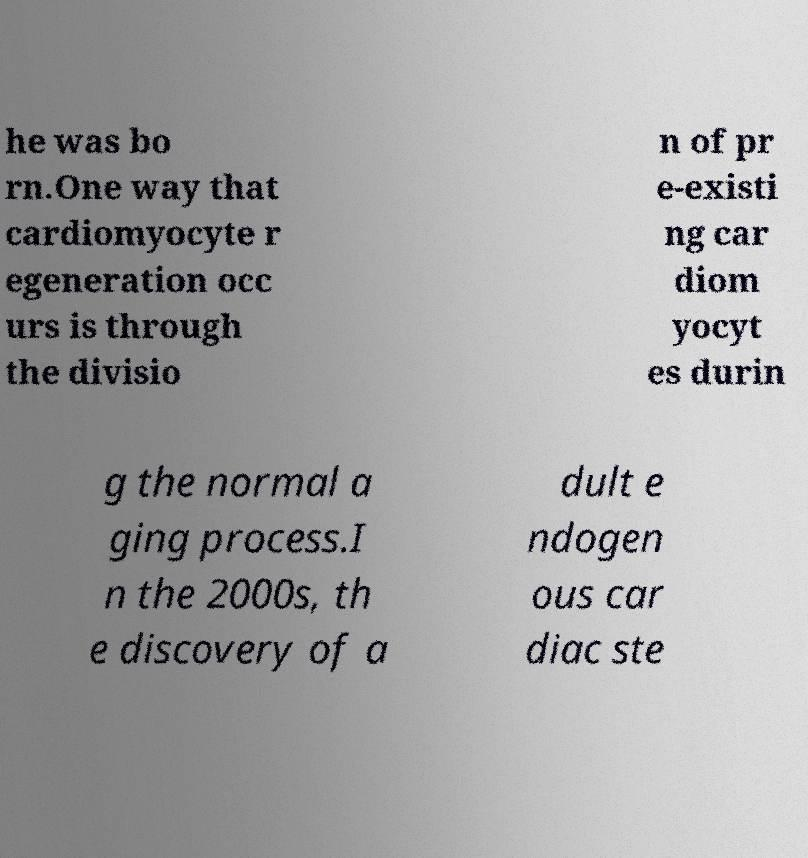Could you assist in decoding the text presented in this image and type it out clearly? he was bo rn.One way that cardiomyocyte r egeneration occ urs is through the divisio n of pr e-existi ng car diom yocyt es durin g the normal a ging process.I n the 2000s, th e discovery of a dult e ndogen ous car diac ste 